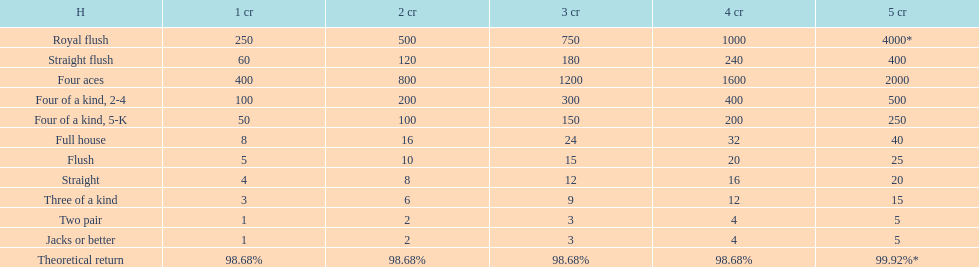How many credits do you have to spend to get at least 2000 in payout if you had four aces? 5 credits. 